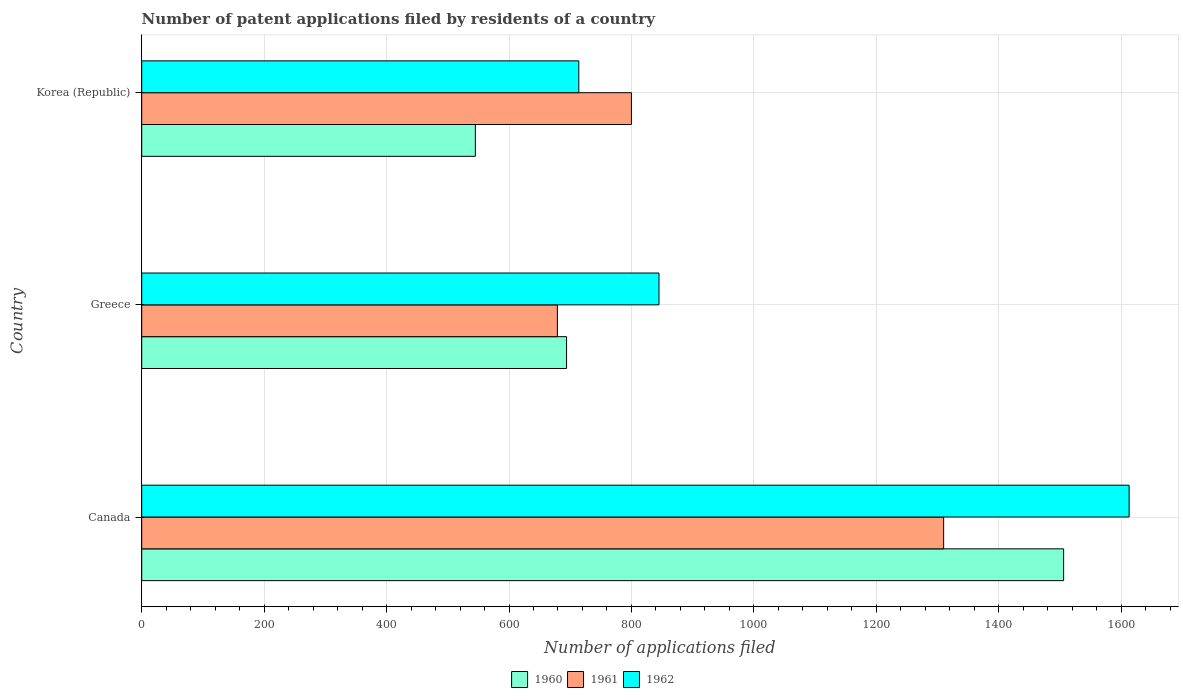Are the number of bars per tick equal to the number of legend labels?
Make the answer very short. Yes. What is the label of the 2nd group of bars from the top?
Make the answer very short. Greece. What is the number of applications filed in 1961 in Korea (Republic)?
Offer a terse response. 800. Across all countries, what is the maximum number of applications filed in 1961?
Ensure brevity in your answer.  1310. Across all countries, what is the minimum number of applications filed in 1960?
Keep it short and to the point. 545. In which country was the number of applications filed in 1960 maximum?
Your answer should be compact. Canada. In which country was the number of applications filed in 1962 minimum?
Offer a very short reply. Korea (Republic). What is the total number of applications filed in 1962 in the graph?
Offer a terse response. 3172. What is the difference between the number of applications filed in 1961 in Canada and that in Korea (Republic)?
Keep it short and to the point. 510. What is the difference between the number of applications filed in 1960 in Canada and the number of applications filed in 1961 in Korea (Republic)?
Your response must be concise. 706. What is the average number of applications filed in 1960 per country?
Your answer should be very brief. 915. What is the difference between the number of applications filed in 1961 and number of applications filed in 1962 in Canada?
Keep it short and to the point. -303. In how many countries, is the number of applications filed in 1960 greater than 1160 ?
Your answer should be compact. 1. What is the ratio of the number of applications filed in 1961 in Greece to that in Korea (Republic)?
Give a very brief answer. 0.85. What is the difference between the highest and the second highest number of applications filed in 1961?
Provide a short and direct response. 510. What is the difference between the highest and the lowest number of applications filed in 1960?
Your answer should be compact. 961. In how many countries, is the number of applications filed in 1961 greater than the average number of applications filed in 1961 taken over all countries?
Provide a short and direct response. 1. Is the sum of the number of applications filed in 1960 in Canada and Korea (Republic) greater than the maximum number of applications filed in 1962 across all countries?
Keep it short and to the point. Yes. What does the 3rd bar from the top in Canada represents?
Make the answer very short. 1960. Is it the case that in every country, the sum of the number of applications filed in 1961 and number of applications filed in 1962 is greater than the number of applications filed in 1960?
Provide a succinct answer. Yes. Are all the bars in the graph horizontal?
Provide a succinct answer. Yes. How many countries are there in the graph?
Your answer should be very brief. 3. What is the difference between two consecutive major ticks on the X-axis?
Provide a succinct answer. 200. Are the values on the major ticks of X-axis written in scientific E-notation?
Give a very brief answer. No. Does the graph contain any zero values?
Make the answer very short. No. How many legend labels are there?
Ensure brevity in your answer.  3. What is the title of the graph?
Your answer should be very brief. Number of patent applications filed by residents of a country. Does "1991" appear as one of the legend labels in the graph?
Your answer should be very brief. No. What is the label or title of the X-axis?
Provide a succinct answer. Number of applications filed. What is the label or title of the Y-axis?
Offer a terse response. Country. What is the Number of applications filed in 1960 in Canada?
Ensure brevity in your answer.  1506. What is the Number of applications filed of 1961 in Canada?
Your answer should be compact. 1310. What is the Number of applications filed of 1962 in Canada?
Your answer should be very brief. 1613. What is the Number of applications filed in 1960 in Greece?
Provide a succinct answer. 694. What is the Number of applications filed of 1961 in Greece?
Offer a very short reply. 679. What is the Number of applications filed of 1962 in Greece?
Your answer should be compact. 845. What is the Number of applications filed in 1960 in Korea (Republic)?
Provide a succinct answer. 545. What is the Number of applications filed of 1961 in Korea (Republic)?
Your response must be concise. 800. What is the Number of applications filed in 1962 in Korea (Republic)?
Provide a succinct answer. 714. Across all countries, what is the maximum Number of applications filed in 1960?
Your answer should be compact. 1506. Across all countries, what is the maximum Number of applications filed in 1961?
Your response must be concise. 1310. Across all countries, what is the maximum Number of applications filed of 1962?
Offer a very short reply. 1613. Across all countries, what is the minimum Number of applications filed in 1960?
Keep it short and to the point. 545. Across all countries, what is the minimum Number of applications filed in 1961?
Make the answer very short. 679. Across all countries, what is the minimum Number of applications filed of 1962?
Provide a short and direct response. 714. What is the total Number of applications filed of 1960 in the graph?
Your response must be concise. 2745. What is the total Number of applications filed in 1961 in the graph?
Keep it short and to the point. 2789. What is the total Number of applications filed in 1962 in the graph?
Offer a very short reply. 3172. What is the difference between the Number of applications filed of 1960 in Canada and that in Greece?
Your answer should be compact. 812. What is the difference between the Number of applications filed in 1961 in Canada and that in Greece?
Provide a succinct answer. 631. What is the difference between the Number of applications filed in 1962 in Canada and that in Greece?
Ensure brevity in your answer.  768. What is the difference between the Number of applications filed of 1960 in Canada and that in Korea (Republic)?
Provide a succinct answer. 961. What is the difference between the Number of applications filed of 1961 in Canada and that in Korea (Republic)?
Make the answer very short. 510. What is the difference between the Number of applications filed of 1962 in Canada and that in Korea (Republic)?
Provide a short and direct response. 899. What is the difference between the Number of applications filed of 1960 in Greece and that in Korea (Republic)?
Give a very brief answer. 149. What is the difference between the Number of applications filed of 1961 in Greece and that in Korea (Republic)?
Offer a terse response. -121. What is the difference between the Number of applications filed in 1962 in Greece and that in Korea (Republic)?
Keep it short and to the point. 131. What is the difference between the Number of applications filed in 1960 in Canada and the Number of applications filed in 1961 in Greece?
Your answer should be compact. 827. What is the difference between the Number of applications filed in 1960 in Canada and the Number of applications filed in 1962 in Greece?
Make the answer very short. 661. What is the difference between the Number of applications filed in 1961 in Canada and the Number of applications filed in 1962 in Greece?
Offer a terse response. 465. What is the difference between the Number of applications filed in 1960 in Canada and the Number of applications filed in 1961 in Korea (Republic)?
Make the answer very short. 706. What is the difference between the Number of applications filed in 1960 in Canada and the Number of applications filed in 1962 in Korea (Republic)?
Your answer should be compact. 792. What is the difference between the Number of applications filed in 1961 in Canada and the Number of applications filed in 1962 in Korea (Republic)?
Keep it short and to the point. 596. What is the difference between the Number of applications filed of 1960 in Greece and the Number of applications filed of 1961 in Korea (Republic)?
Provide a succinct answer. -106. What is the difference between the Number of applications filed of 1961 in Greece and the Number of applications filed of 1962 in Korea (Republic)?
Keep it short and to the point. -35. What is the average Number of applications filed in 1960 per country?
Your answer should be very brief. 915. What is the average Number of applications filed in 1961 per country?
Your answer should be compact. 929.67. What is the average Number of applications filed of 1962 per country?
Provide a succinct answer. 1057.33. What is the difference between the Number of applications filed in 1960 and Number of applications filed in 1961 in Canada?
Give a very brief answer. 196. What is the difference between the Number of applications filed in 1960 and Number of applications filed in 1962 in Canada?
Give a very brief answer. -107. What is the difference between the Number of applications filed of 1961 and Number of applications filed of 1962 in Canada?
Offer a very short reply. -303. What is the difference between the Number of applications filed in 1960 and Number of applications filed in 1961 in Greece?
Your answer should be compact. 15. What is the difference between the Number of applications filed of 1960 and Number of applications filed of 1962 in Greece?
Make the answer very short. -151. What is the difference between the Number of applications filed of 1961 and Number of applications filed of 1962 in Greece?
Provide a short and direct response. -166. What is the difference between the Number of applications filed in 1960 and Number of applications filed in 1961 in Korea (Republic)?
Give a very brief answer. -255. What is the difference between the Number of applications filed in 1960 and Number of applications filed in 1962 in Korea (Republic)?
Your response must be concise. -169. What is the difference between the Number of applications filed in 1961 and Number of applications filed in 1962 in Korea (Republic)?
Your answer should be very brief. 86. What is the ratio of the Number of applications filed in 1960 in Canada to that in Greece?
Provide a succinct answer. 2.17. What is the ratio of the Number of applications filed of 1961 in Canada to that in Greece?
Offer a terse response. 1.93. What is the ratio of the Number of applications filed of 1962 in Canada to that in Greece?
Provide a succinct answer. 1.91. What is the ratio of the Number of applications filed in 1960 in Canada to that in Korea (Republic)?
Offer a very short reply. 2.76. What is the ratio of the Number of applications filed of 1961 in Canada to that in Korea (Republic)?
Provide a succinct answer. 1.64. What is the ratio of the Number of applications filed of 1962 in Canada to that in Korea (Republic)?
Offer a terse response. 2.26. What is the ratio of the Number of applications filed of 1960 in Greece to that in Korea (Republic)?
Offer a terse response. 1.27. What is the ratio of the Number of applications filed in 1961 in Greece to that in Korea (Republic)?
Offer a terse response. 0.85. What is the ratio of the Number of applications filed in 1962 in Greece to that in Korea (Republic)?
Ensure brevity in your answer.  1.18. What is the difference between the highest and the second highest Number of applications filed in 1960?
Your answer should be very brief. 812. What is the difference between the highest and the second highest Number of applications filed of 1961?
Offer a very short reply. 510. What is the difference between the highest and the second highest Number of applications filed of 1962?
Provide a short and direct response. 768. What is the difference between the highest and the lowest Number of applications filed of 1960?
Your answer should be very brief. 961. What is the difference between the highest and the lowest Number of applications filed in 1961?
Offer a terse response. 631. What is the difference between the highest and the lowest Number of applications filed in 1962?
Provide a short and direct response. 899. 